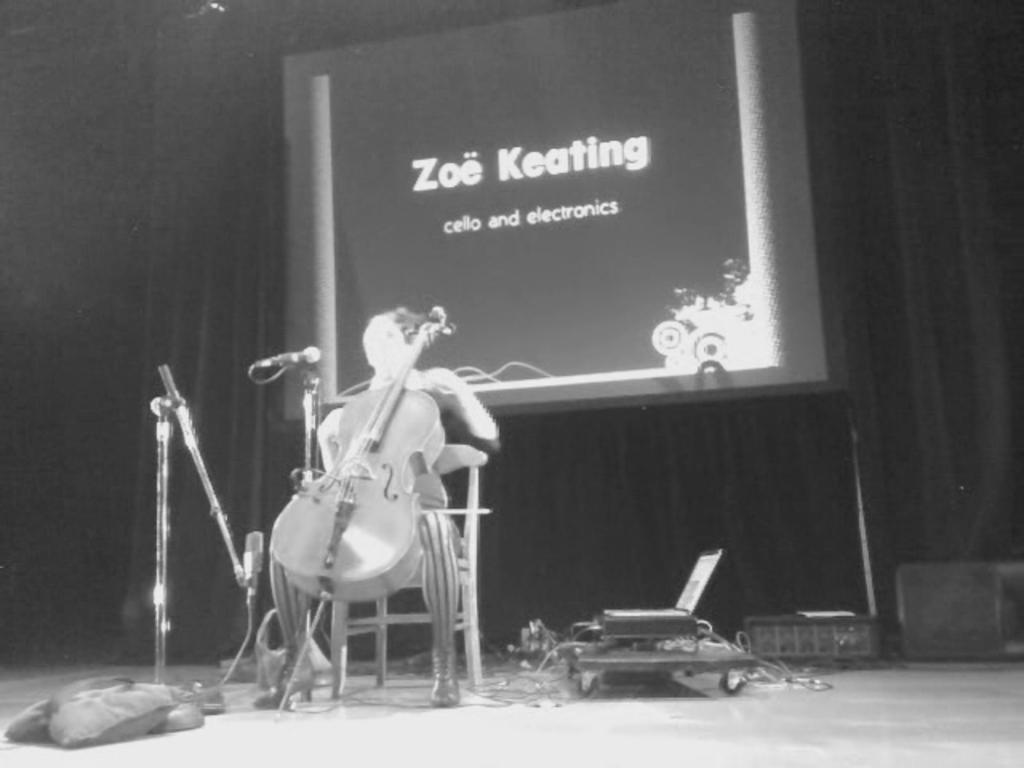What type of image is present in the picture? There is an old photograph in the image. What is the person in the photograph doing? The person is sitting on a chair in the photograph. What object is the person holding in the photograph? The person is holding a musical instrument in the photograph. What equipment can be seen in the image? There are microphones visible in the image. What type of covering is present in the image? There is a curtain in the image. What flat, rigid surface is visible in the image? There is a board in the image. How many clocks are visible in the image? There are no clocks visible in the image. What advice does the person's father give in the image? There is no reference to a father or any advice in the image. 